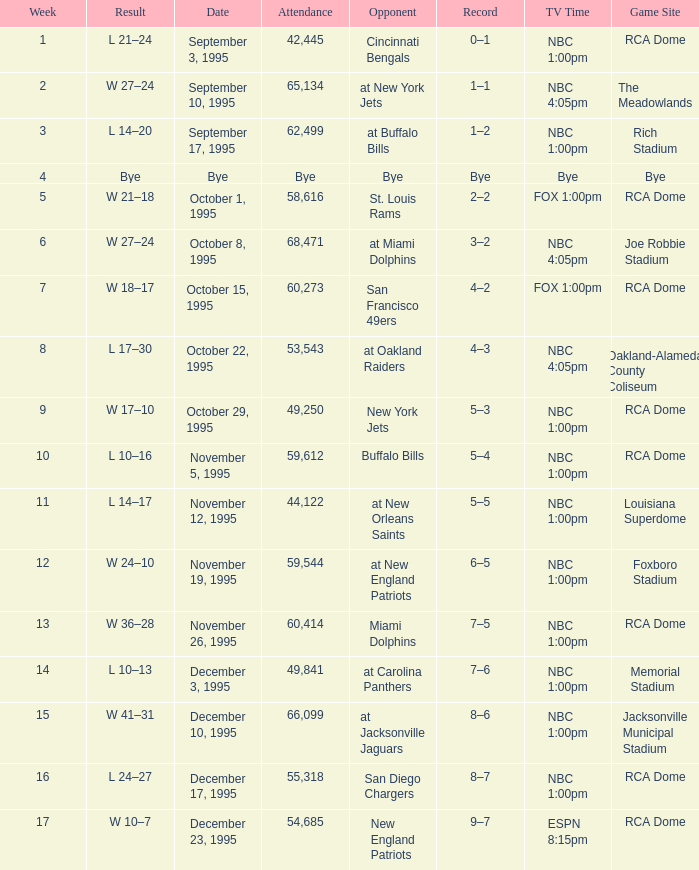What's the Opponent with a Week that's larger than 16? New England Patriots. 